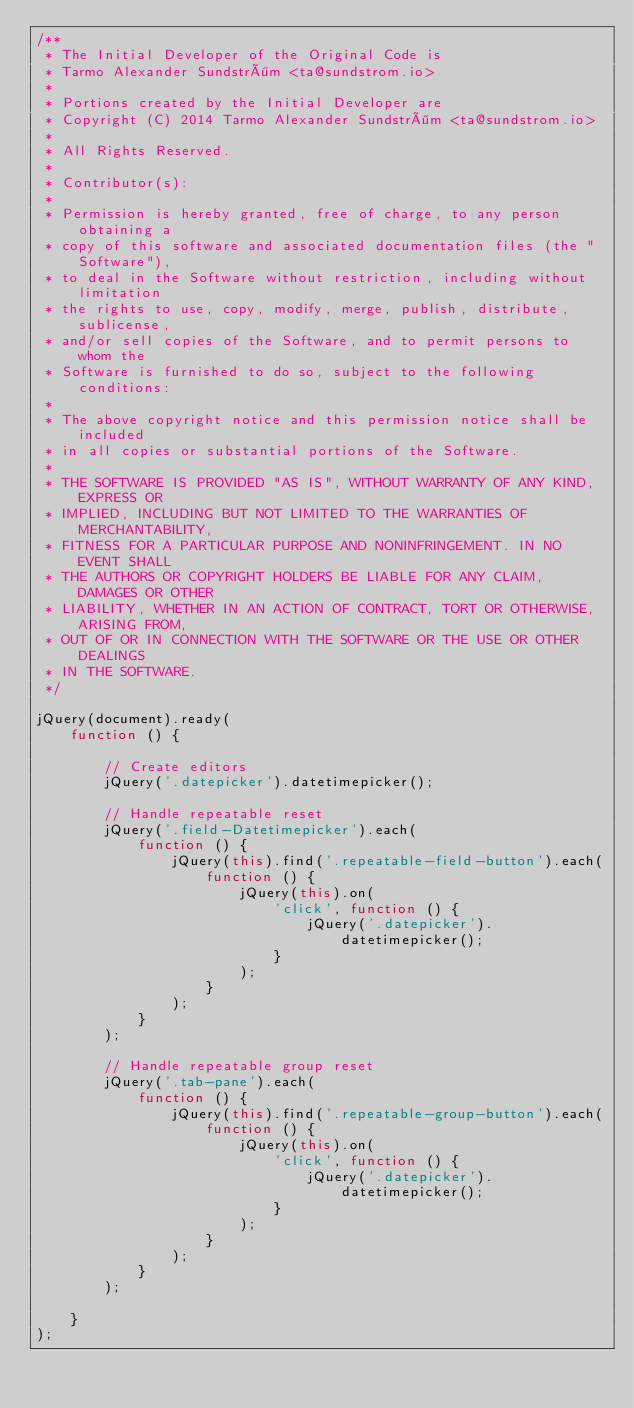<code> <loc_0><loc_0><loc_500><loc_500><_JavaScript_>/**
 * The Initial Developer of the Original Code is
 * Tarmo Alexander Sundström <ta@sundstrom.io>
 *
 * Portions created by the Initial Developer are
 * Copyright (C) 2014 Tarmo Alexander Sundström <ta@sundstrom.io>
 *
 * All Rights Reserved.
 *
 * Contributor(s):
 *
 * Permission is hereby granted, free of charge, to any person obtaining a
 * copy of this software and associated documentation files (the "Software"),
 * to deal in the Software without restriction, including without limitation
 * the rights to use, copy, modify, merge, publish, distribute, sublicense,
 * and/or sell copies of the Software, and to permit persons to whom the
 * Software is furnished to do so, subject to the following conditions:
 *
 * The above copyright notice and this permission notice shall be included
 * in all copies or substantial portions of the Software.
 *
 * THE SOFTWARE IS PROVIDED "AS IS", WITHOUT WARRANTY OF ANY KIND, EXPRESS OR
 * IMPLIED, INCLUDING BUT NOT LIMITED TO THE WARRANTIES OF MERCHANTABILITY,
 * FITNESS FOR A PARTICULAR PURPOSE AND NONINFRINGEMENT. IN NO EVENT SHALL
 * THE AUTHORS OR COPYRIGHT HOLDERS BE LIABLE FOR ANY CLAIM, DAMAGES OR OTHER
 * LIABILITY, WHETHER IN AN ACTION OF CONTRACT, TORT OR OTHERWISE, ARISING FROM,
 * OUT OF OR IN CONNECTION WITH THE SOFTWARE OR THE USE OR OTHER DEALINGS
 * IN THE SOFTWARE.
 */

jQuery(document).ready(
    function () {

        // Create editors
        jQuery('.datepicker').datetimepicker();

        // Handle repeatable reset
        jQuery('.field-Datetimepicker').each(
            function () {
                jQuery(this).find('.repeatable-field-button').each(
                    function () {
                        jQuery(this).on(
                            'click', function () {
                                jQuery('.datepicker').datetimepicker();
                            }
                        );
                    }
                ); 
            }
        );

        // Handle repeatable group reset
        jQuery('.tab-pane').each(
            function () {
                jQuery(this).find('.repeatable-group-button').each(
                    function () {
                        jQuery(this).on(
                            'click', function () {
                                jQuery('.datepicker').datetimepicker();
                            }
                        );
                    }
                ); 
            }
        );

    }
);
</code> 